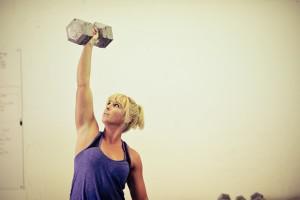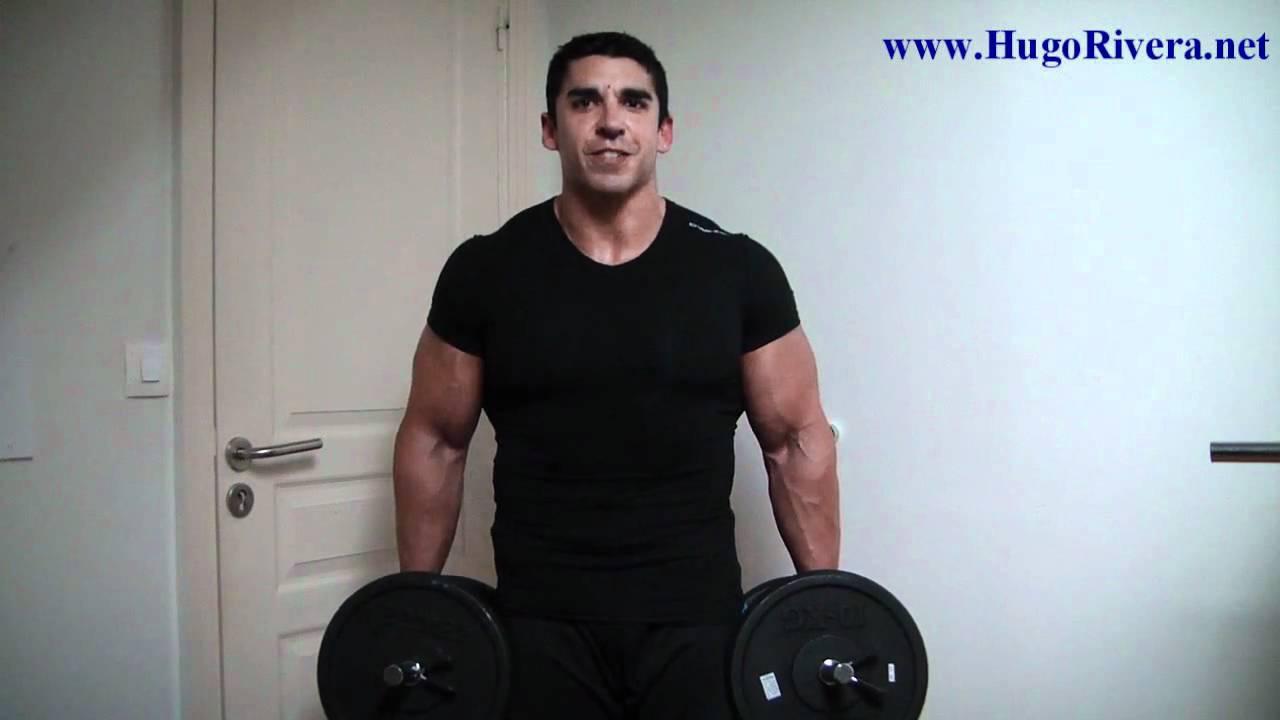The first image is the image on the left, the second image is the image on the right. For the images displayed, is the sentence "At least one athlete performing a dumbbell workout is a blonde woman in a purple tanktop." factually correct? Answer yes or no. Yes. The first image is the image on the left, the second image is the image on the right. Examine the images to the left and right. Is the description "The person in the image on the left is lifting a single weight with one hand." accurate? Answer yes or no. Yes. 